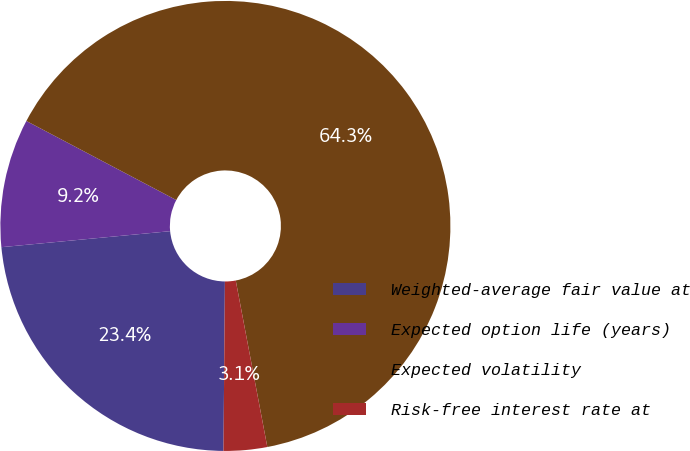Convert chart. <chart><loc_0><loc_0><loc_500><loc_500><pie_chart><fcel>Weighted-average fair value at<fcel>Expected option life (years)<fcel>Expected volatility<fcel>Risk-free interest rate at<nl><fcel>23.36%<fcel>9.23%<fcel>64.29%<fcel>3.12%<nl></chart> 